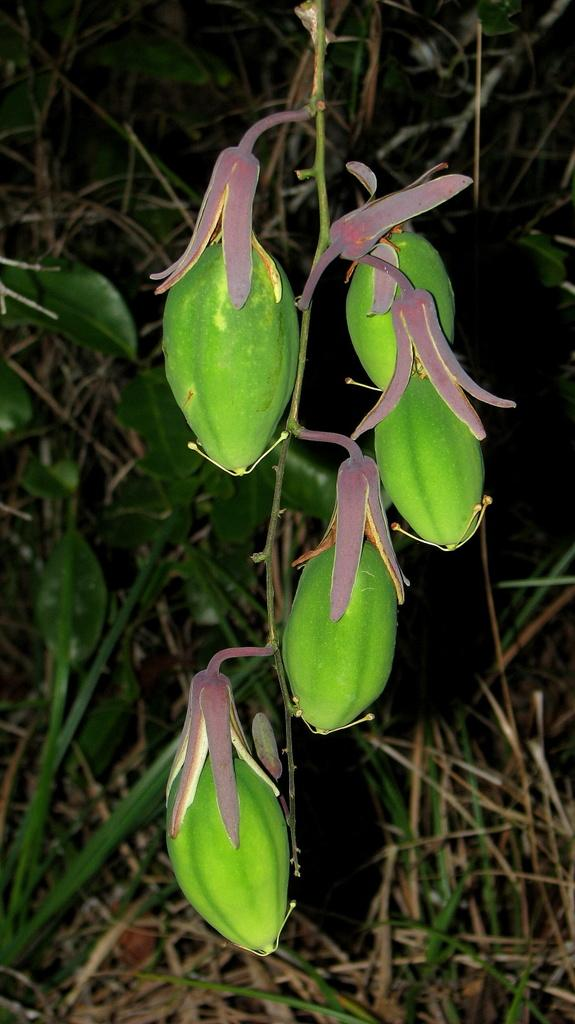What type of food can be seen in the image? There are fruits in the image. What is the color of the background in the image? The background of the image is dark. What can be seen in the background of the image besides the dark color? Dry grass and plants are visible in the background of the image. How much money is being offered to the plants in the image? There is no money present in the image, and the plants are not being offered any money. 